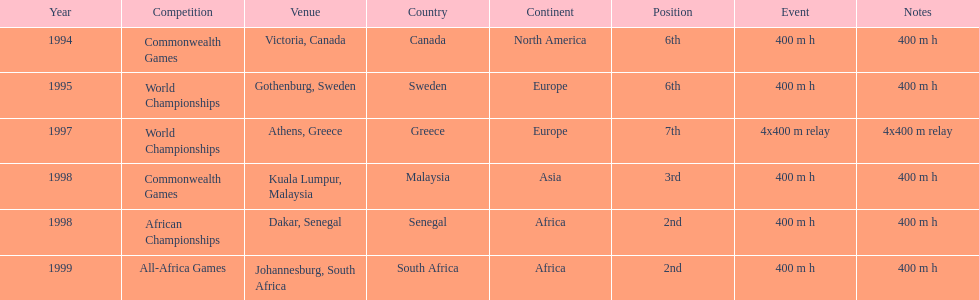Which year had the most competitions? 1998. 